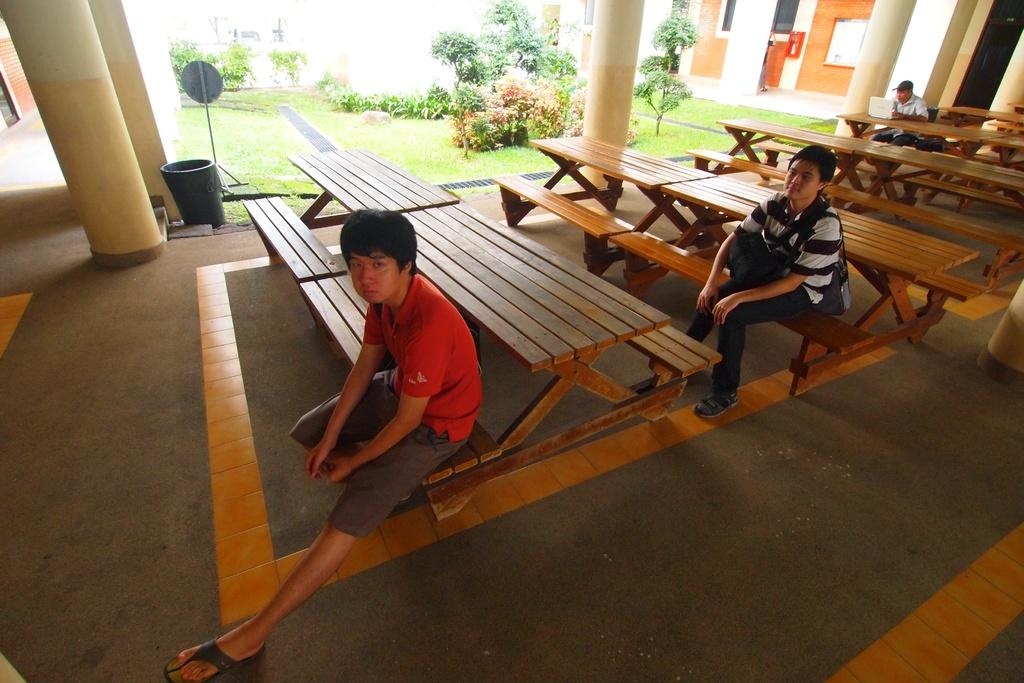What type of seating is available in the image? There are wooden benches in the image. How many people are seated on the benches? Three people are seated on the benches. What architectural features can be seen in the image? There are pillars visible in the image. What type of vegetation is present in the image? Trees are present in the image. What structure is located in the right corner of the image? There is a building in the right corner of the image. What type of paste is being used for the treatment of the sticks in the image? There is no paste, treatment, or sticks present in the image. 